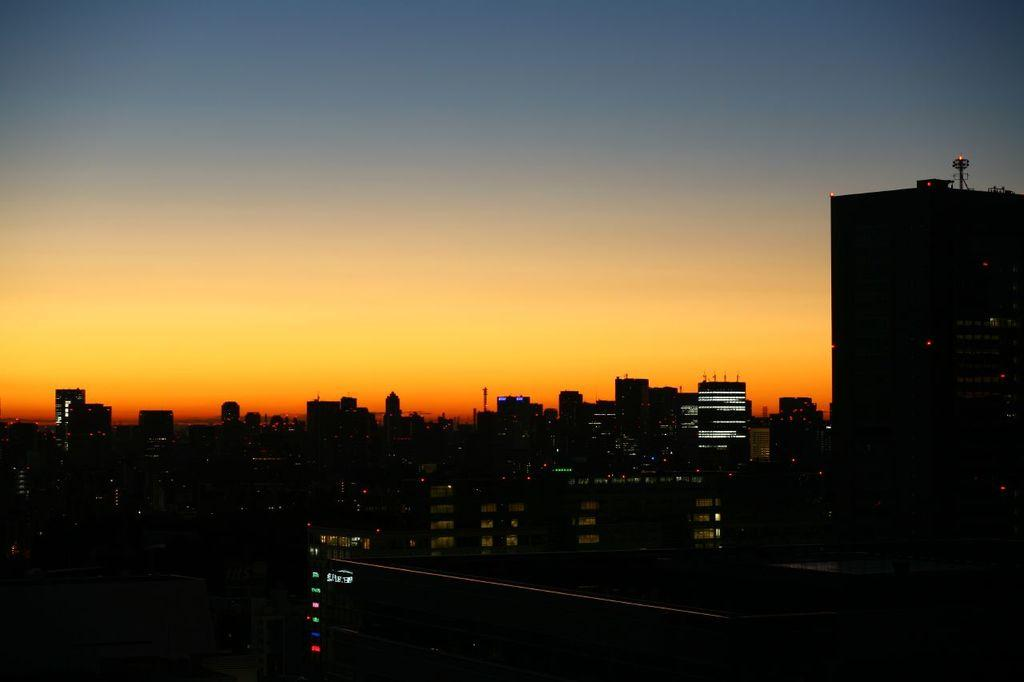What type of structures are located at the bottom of the image? There are buildings at the bottom of the image. What can be seen at the top of the image? The sky is visible at the top of the image. Where is the tall building in the image? The tall building is on the right side of the image. What feature does the tall building have? The tall building has towers on it. Can you see the thumb of the person who drew the image? There is no reference to a person or their thumb in the image, so it is not possible to answer that question. 